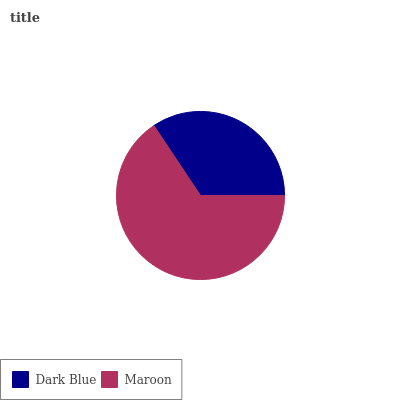Is Dark Blue the minimum?
Answer yes or no. Yes. Is Maroon the maximum?
Answer yes or no. Yes. Is Maroon the minimum?
Answer yes or no. No. Is Maroon greater than Dark Blue?
Answer yes or no. Yes. Is Dark Blue less than Maroon?
Answer yes or no. Yes. Is Dark Blue greater than Maroon?
Answer yes or no. No. Is Maroon less than Dark Blue?
Answer yes or no. No. Is Maroon the high median?
Answer yes or no. Yes. Is Dark Blue the low median?
Answer yes or no. Yes. Is Dark Blue the high median?
Answer yes or no. No. Is Maroon the low median?
Answer yes or no. No. 